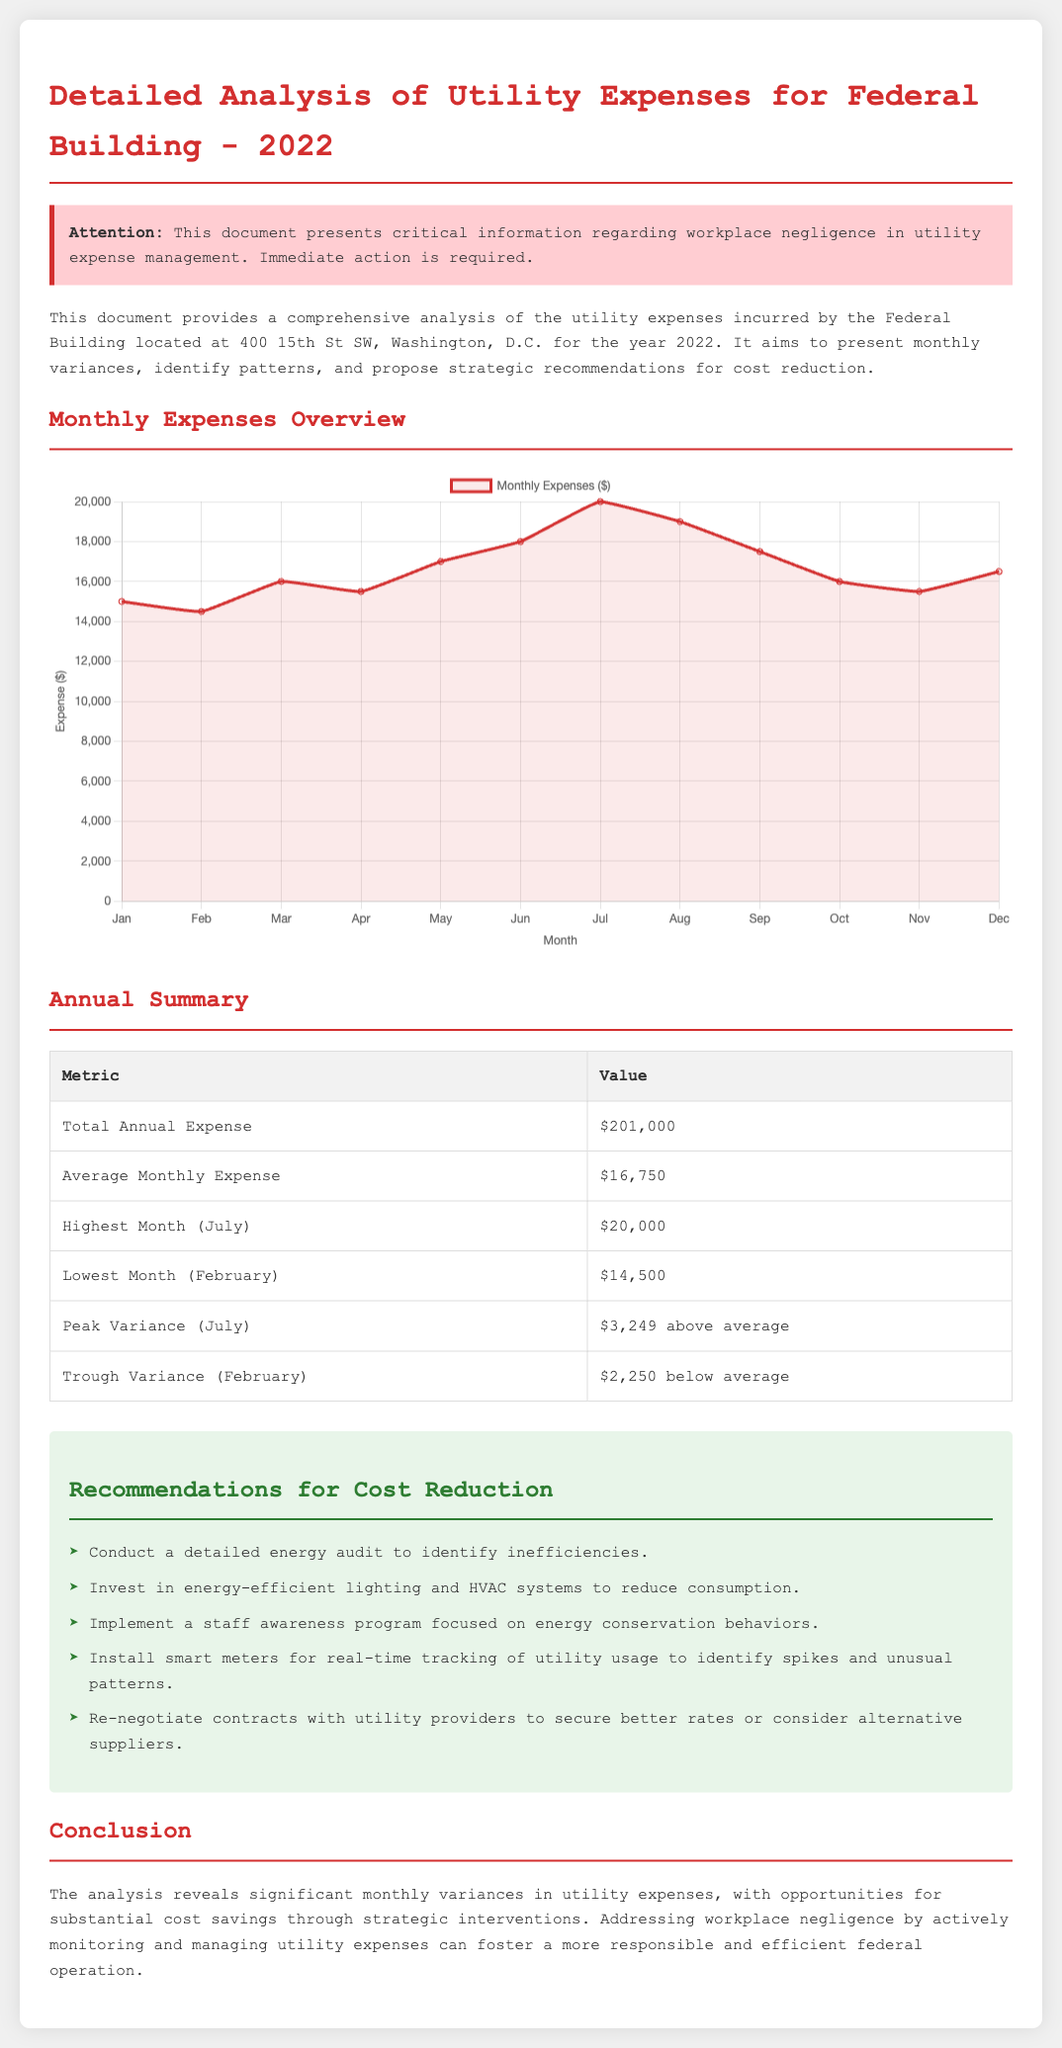What is the total annual expense? The total annual expense is explicitly stated in the document, which is $201,000.
Answer: $201,000 What month had the highest expenses? The month with the highest expenses is indicated in the annual summary, which is July.
Answer: July What is the average monthly expense? The average monthly expense is provided in the annual summary section as $16,750.
Answer: $16,750 What was the peak variance month? The peak variance month is determined from the annual summary, which is July with a variance of $3,249 above average.
Answer: July What is one recommendation for cost reduction? A recommendation for cost reduction is mentioned in the recommendations section and one example is conducting a detailed energy audit.
Answer: Conduct a detailed energy audit What were the lowest expenses in a month? The document specifies the lowest monthly expenses occurred in February, which is stated to be $14,500.
Answer: $14,500 What type of chart is used to present monthly expenses? The document describes the type of chart used as a line chart for visualizing monthly expenses.
Answer: Line chart What is the trough variance amount? The trough variance amount is specified in the document as $2,250 below average for the month of February.
Answer: $2,250 What urgent issue does the alert section highlight? The alert section emphasizes critical information regarding workplace negligence in utility expense management requiring immediate action.
Answer: Workplace negligence 